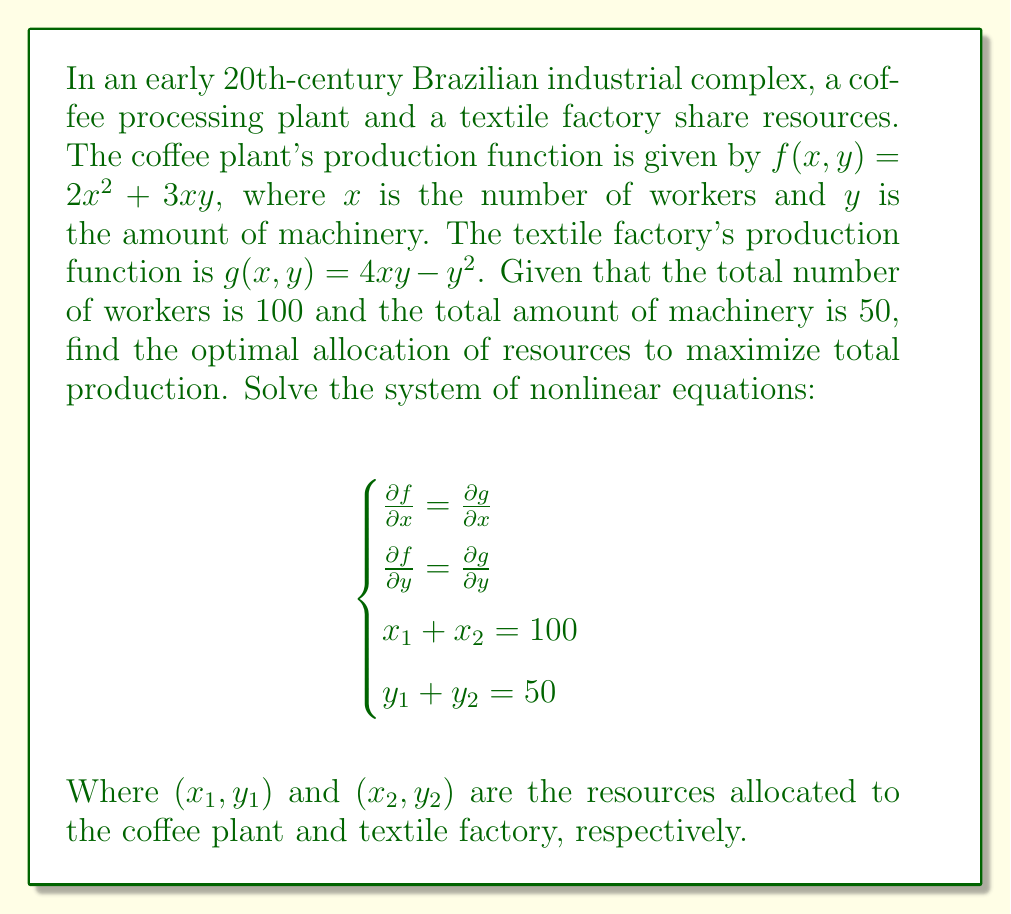Give your solution to this math problem. To solve this system of nonlinear equations, we'll follow these steps:

1) First, let's calculate the partial derivatives:

   For $f(x,y) = 2x^2 + 3xy$:
   $\frac{\partial f}{\partial x} = 4x + 3y$
   $\frac{\partial f}{\partial y} = 3x$

   For $g(x,y) = 4xy - y^2$:
   $\frac{\partial g}{\partial x} = 4y$
   $\frac{\partial g}{\partial y} = 4x - 2y$

2) Now, we can set up our system of equations:

   $$\begin{cases}
   4x_1 + 3y_1 = 4y_2 \\
   3x_1 = 4x_2 - 2y_2 \\
   x_1 + x_2 = 100 \\
   y_1 + y_2 = 50
   \end{cases}$$

3) From the second equation: $x_1 = \frac{4x_2 - 2y_2}{3}$

4) Substitute this into the third equation:
   $\frac{4x_2 - 2y_2}{3} + x_2 = 100$
   $4x_2 - 2y_2 + 3x_2 = 300$
   $7x_2 - 2y_2 = 300$

5) From the first equation: $4x_1 + 3y_1 = 4y_2$
   Substitute $x_1 = 100 - x_2$ and $y_1 = 50 - y_2$:
   $4(100 - x_2) + 3(50 - y_2) = 4y_2$
   $400 - 4x_2 + 150 - 3y_2 = 4y_2$
   $550 - 4x_2 = 7y_2$

6) Now we have two equations:
   $7x_2 - 2y_2 = 300$
   $4x_2 + 7y_2 = 550$

7) Multiply the first equation by 4 and the second by 7:
   $28x_2 - 8y_2 = 1200$
   $28x_2 + 49y_2 = 3850$

8) Subtracting these equations eliminates $x_2$:
   $57y_2 = 2650$
   $y_2 = \frac{2650}{57} \approx 46.49$

9) Substitute this back into $7x_2 - 2y_2 = 300$:
   $7x_2 - 2(46.49) = 300$
   $7x_2 = 392.98$
   $x_2 = 56.14$

10) Now we can find $x_1$ and $y_1$:
    $x_1 = 100 - x_2 = 100 - 56.14 = 43.86$
    $y_1 = 50 - y_2 = 50 - 46.49 = 3.51$

Therefore, the optimal allocation is approximately:
Coffee plant: 44 workers and 4 units of machinery
Textile factory: 56 workers and 46 units of machinery
Answer: Coffee plant: (44, 4), Textile factory: (56, 46) 